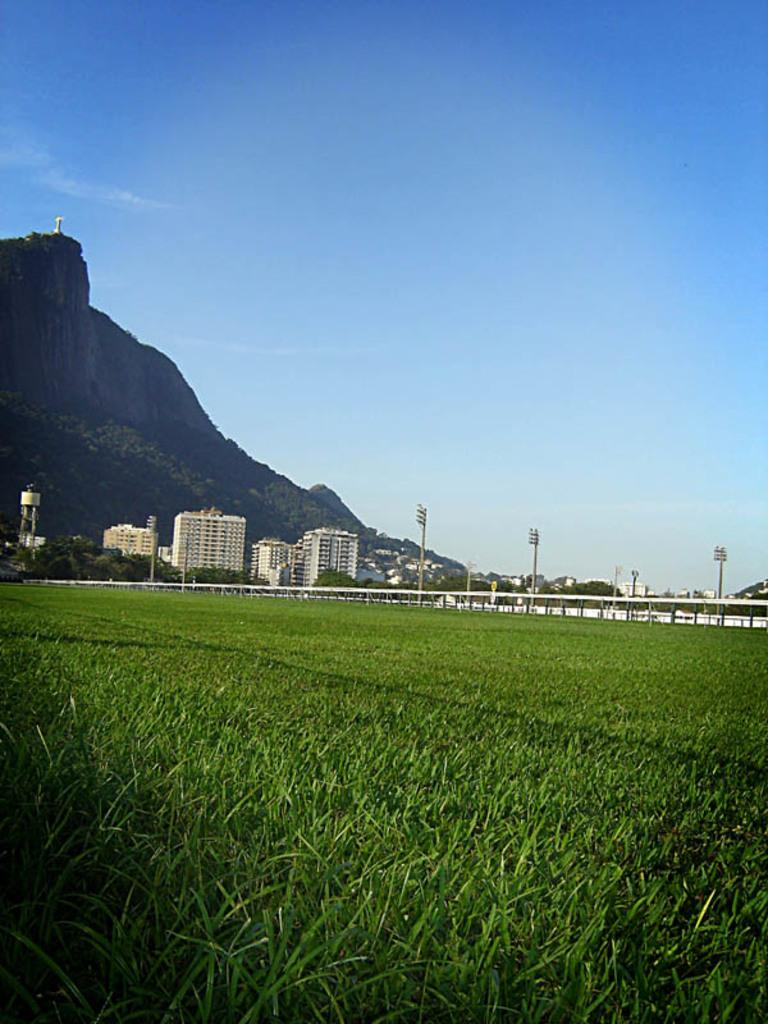What type of vegetation is present in the image? There is grass in the image. What structure can be seen in the image? There is a railing in the image. What objects are present in the image that might be used for support or guidance? There are poles in the image. What can be seen in the distance in the background of the image? There are buildings, mountains, and the sky visible in the background of the image. What type of powder is being used to create the mountains in the image? There is no powder present in the image, and the mountains are not created using any such substance. 